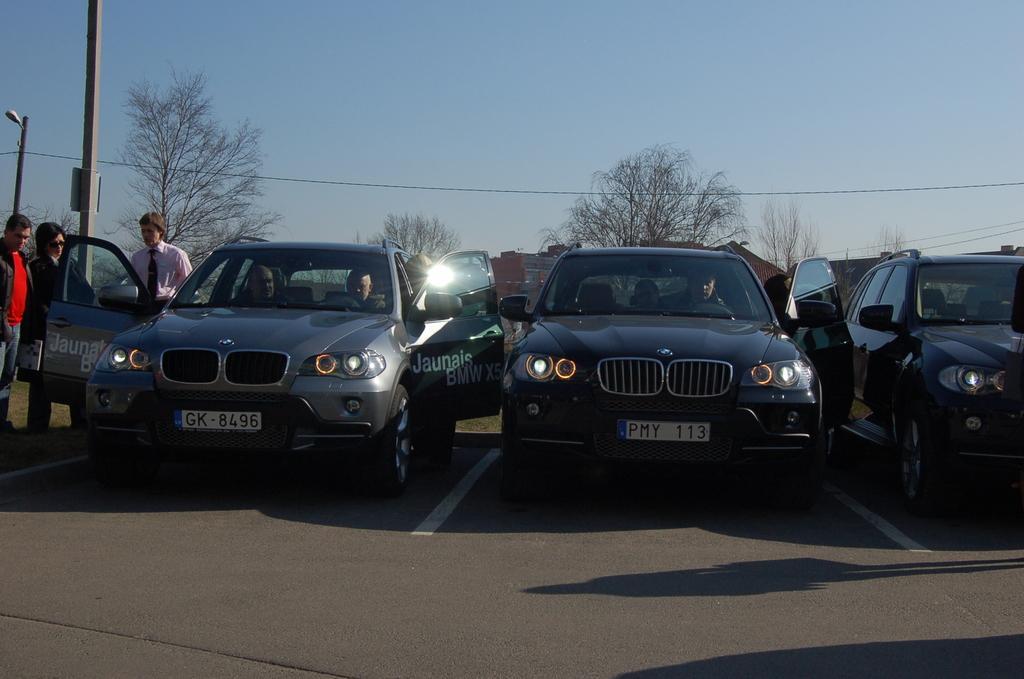Could you give a brief overview of what you see in this image? These are the cars, which are parked. I can see few people standing and few people sitting in the cars. I can see the trees. This looks like a pole. Here is the sky. In the background, I can see the buildings. 